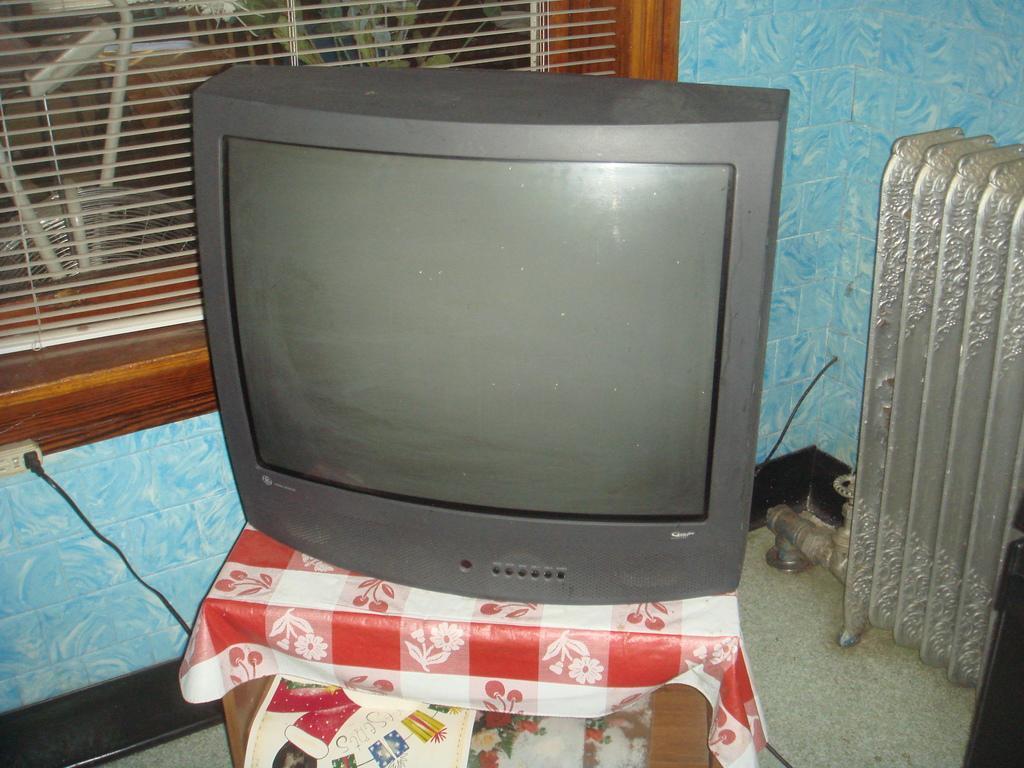Describe this image in one or two sentences. In this picture I can observe television in the middle of the picture. In the bottom of the picture I can observe a stool. In the background I can observe window blinds. 